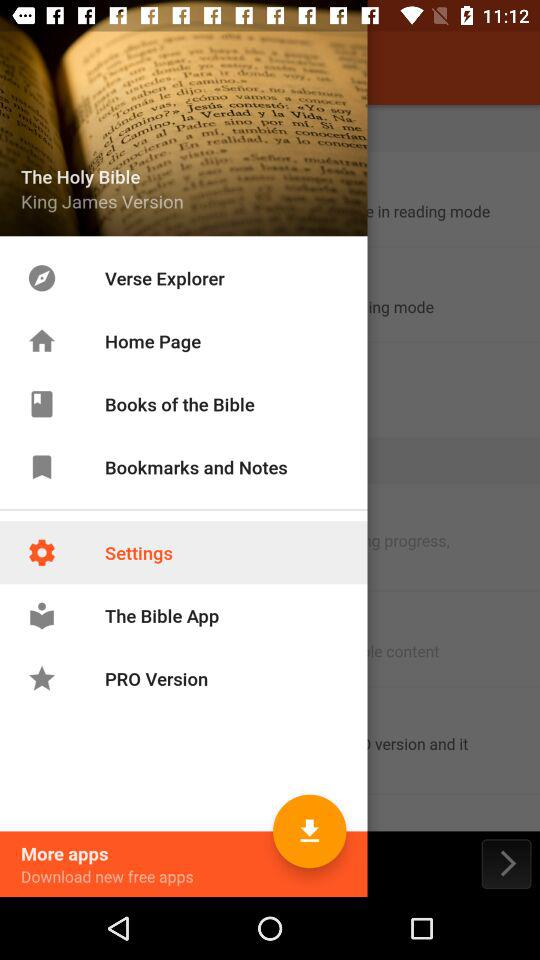What is the title of the book? The title of the book is "The Holy Bible". 